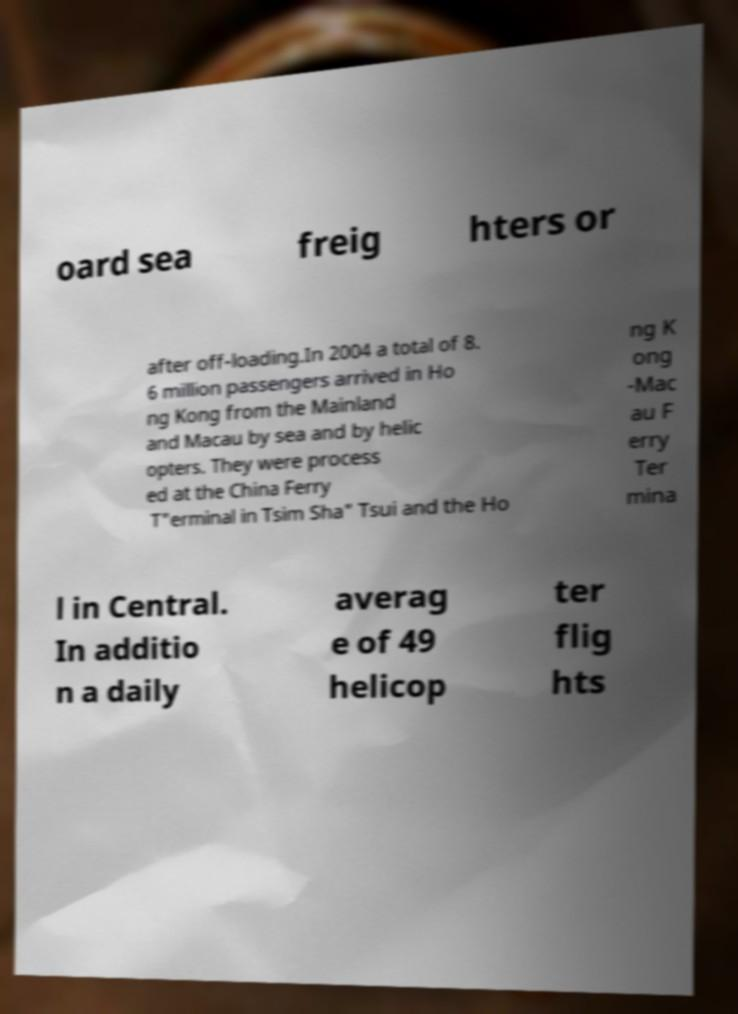Could you assist in decoding the text presented in this image and type it out clearly? oard sea freig hters or after off-loading.In 2004 a total of 8. 6 million passengers arrived in Ho ng Kong from the Mainland and Macau by sea and by helic opters. They were process ed at the China Ferry T"erminal in Tsim Sha" Tsui and the Ho ng K ong -Mac au F erry Ter mina l in Central. In additio n a daily averag e of 49 helicop ter flig hts 